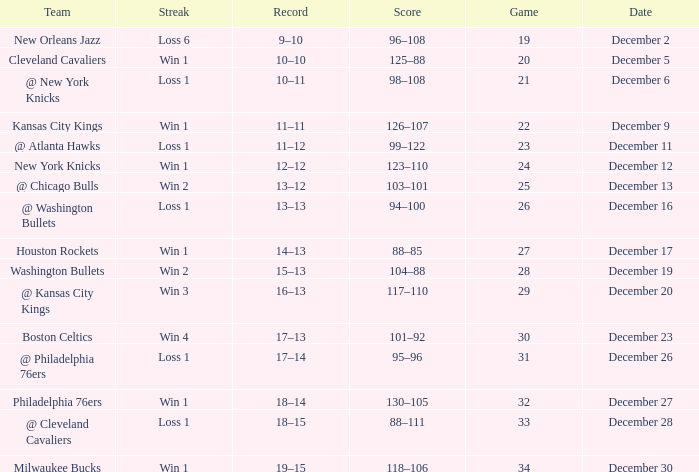What is the Score of the Game with a Record of 13–12? 103–101. Give me the full table as a dictionary. {'header': ['Team', 'Streak', 'Record', 'Score', 'Game', 'Date'], 'rows': [['New Orleans Jazz', 'Loss 6', '9–10', '96–108', '19', 'December 2'], ['Cleveland Cavaliers', 'Win 1', '10–10', '125–88', '20', 'December 5'], ['@ New York Knicks', 'Loss 1', '10–11', '98–108', '21', 'December 6'], ['Kansas City Kings', 'Win 1', '11–11', '126–107', '22', 'December 9'], ['@ Atlanta Hawks', 'Loss 1', '11–12', '99–122', '23', 'December 11'], ['New York Knicks', 'Win 1', '12–12', '123–110', '24', 'December 12'], ['@ Chicago Bulls', 'Win 2', '13–12', '103–101', '25', 'December 13'], ['@ Washington Bullets', 'Loss 1', '13–13', '94–100', '26', 'December 16'], ['Houston Rockets', 'Win 1', '14–13', '88–85', '27', 'December 17'], ['Washington Bullets', 'Win 2', '15–13', '104–88', '28', 'December 19'], ['@ Kansas City Kings', 'Win 3', '16–13', '117–110', '29', 'December 20'], ['Boston Celtics', 'Win 4', '17–13', '101–92', '30', 'December 23'], ['@ Philadelphia 76ers', 'Loss 1', '17–14', '95–96', '31', 'December 26'], ['Philadelphia 76ers', 'Win 1', '18–14', '130–105', '32', 'December 27'], ['@ Cleveland Cavaliers', 'Loss 1', '18–15', '88–111', '33', 'December 28'], ['Milwaukee Bucks', 'Win 1', '19–15', '118–106', '34', 'December 30']]} 